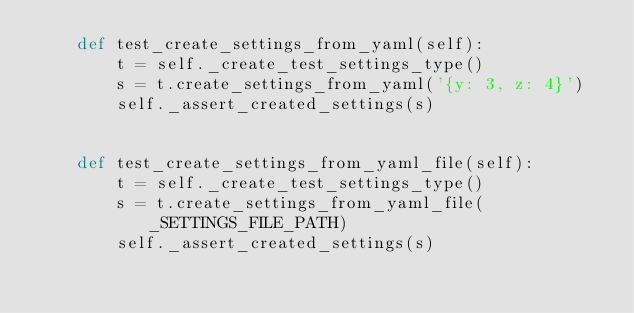Convert code to text. <code><loc_0><loc_0><loc_500><loc_500><_Python_>    def test_create_settings_from_yaml(self):
        t = self._create_test_settings_type()
        s = t.create_settings_from_yaml('{y: 3, z: 4}')
        self._assert_created_settings(s)
        
        
    def test_create_settings_from_yaml_file(self):
        t = self._create_test_settings_type()
        s = t.create_settings_from_yaml_file(_SETTINGS_FILE_PATH)
        self._assert_created_settings(s)
</code> 